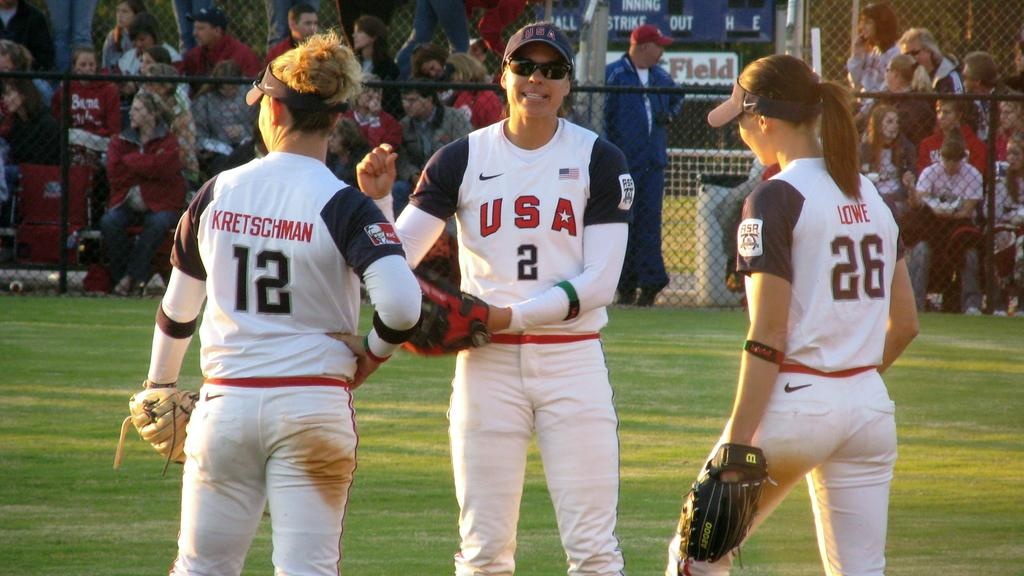<image>
Provide a brief description of the given image. Three women in U.S.A baseball uniforms are on the field. 